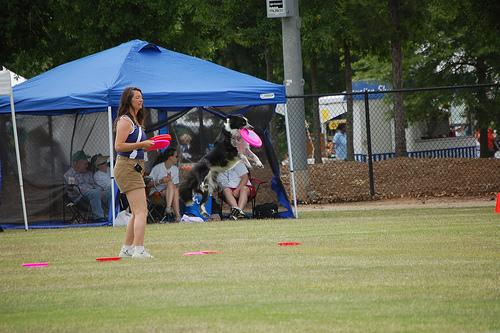In the product advertisement task, describe a suitable advertisement for promoting frisbees in this image. Introducing our new range of brightly colored frisbees - perfect for fun day out with friends and family. Even your dog will love jumping and catching them! Experience limitless fun under the sun! Tell me briefly what the black and white dog is doing in the image. The black and white dog is jumping and catching a frisbee. In a public park scene, which type of fence is installed around to safeguard the area? A black chain-linked fence is installed around the park area. What color are the shorts of the woman holding frisbees? The woman holding frisbees is wearing brown shorts. In the visual entailment task, describe the interaction between the woman wearing brown shorts and the pink frisbee. The woman wearing brown shorts is holding the pink frisbee in her hand and potentially preparing to throw it. List three objects or people that are present inside the blue tent. People sitting, old man wearing a green ball cap, and people sitting in the back under the tent. For the multi-choice VQA task, choose the correct answer: What color is the tent in the picture? a) Red b) Blue c) Green d) Yellow b) Blue Identify the color and type of frisbee a woman holding. A woman is holding a pink frisbee. 